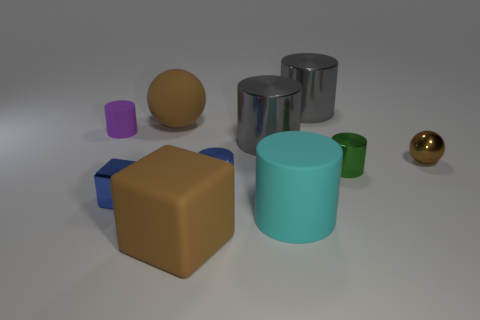Can you guess the purpose of these objects? Without additional context, it's challenging to determine a specific purpose. However, these objects could serve as models for a 3D visualization, prototypes for a product design, elements in an educational set for geometry learning, or simply decorative pieces. 